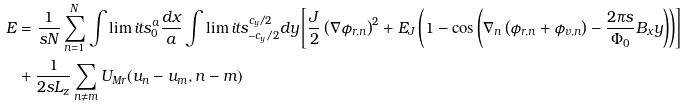Convert formula to latex. <formula><loc_0><loc_0><loc_500><loc_500>E & = \frac { 1 } { s N } \sum _ { n = 1 } ^ { N } \int \lim i t s _ { 0 } ^ { a } \frac { d x } { a } \int \lim i t s _ { - c _ { y } / 2 } ^ { c _ { y } / 2 } d y \left [ \frac { J } { 2 } \left ( \nabla \phi _ { r , n } \right ) ^ { 2 } + E _ { J } \left ( 1 - \cos \left ( \nabla _ { n } \left ( \phi _ { r , n } + \phi _ { v , n } \right ) - \frac { 2 \pi s } { \Phi _ { 0 } } B _ { x } y \right ) \right ) \right ] \\ & + \frac { 1 } { 2 s L _ { z } } \sum _ { n \neq m } U _ { M r } ( u _ { n } - u _ { m } , n - m )</formula> 